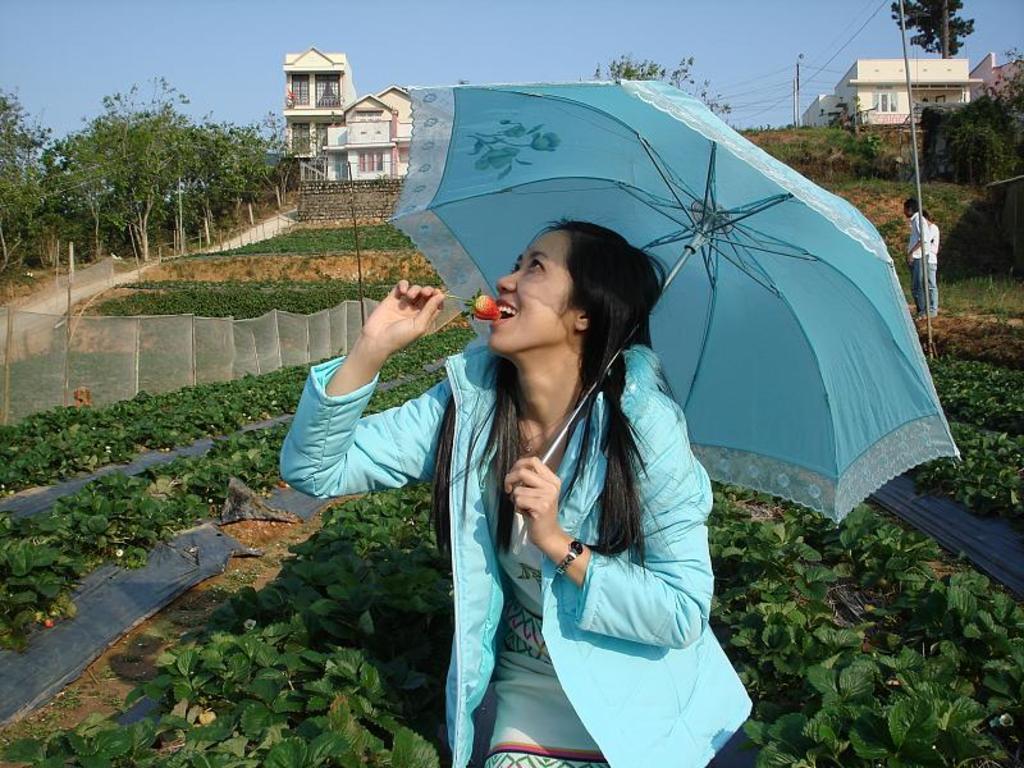Could you give a brief overview of what you see in this image? In the center of the image, we can see a lady wearing a coat and holding an umbrella and a strawberry. In the background, there are some other people and poles along with wires, trees, buildings, a fence and some plants. At the top, there is sky. 